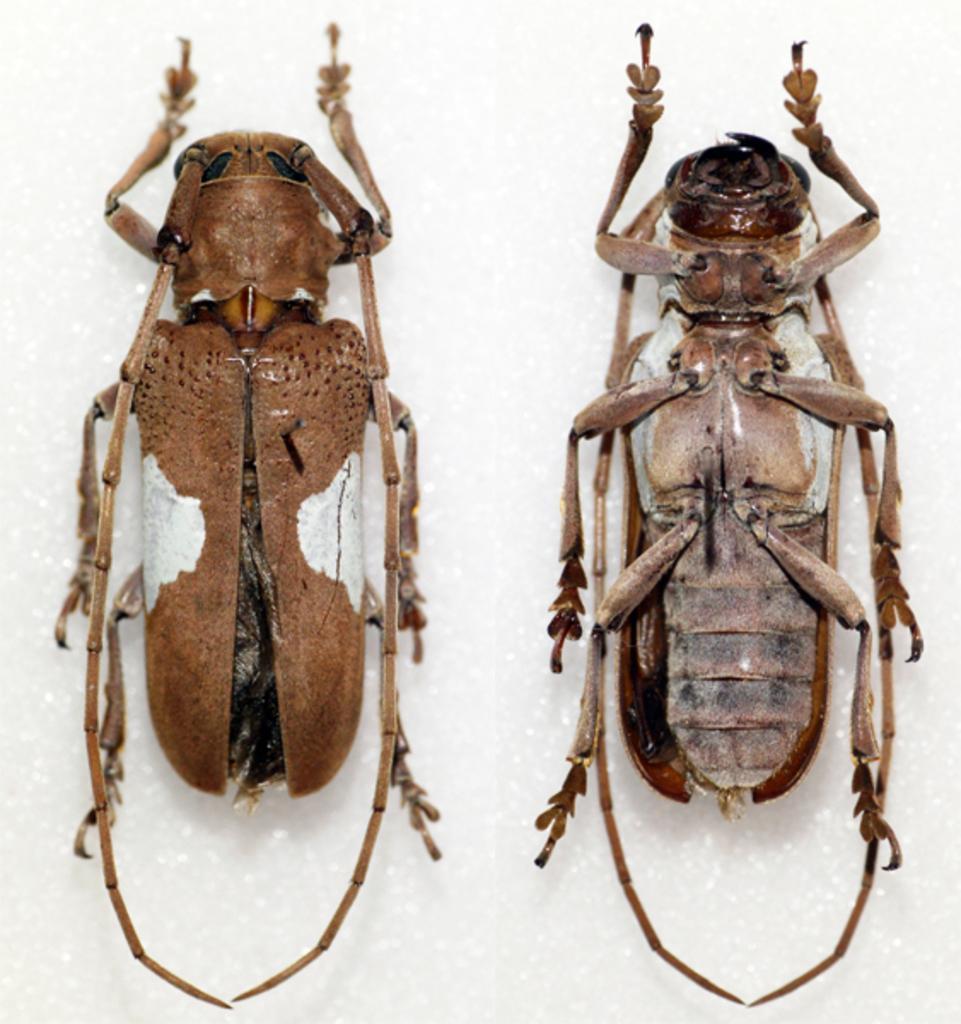Could you give a brief overview of what you see in this image? In this image, in the middle there are two insects. 